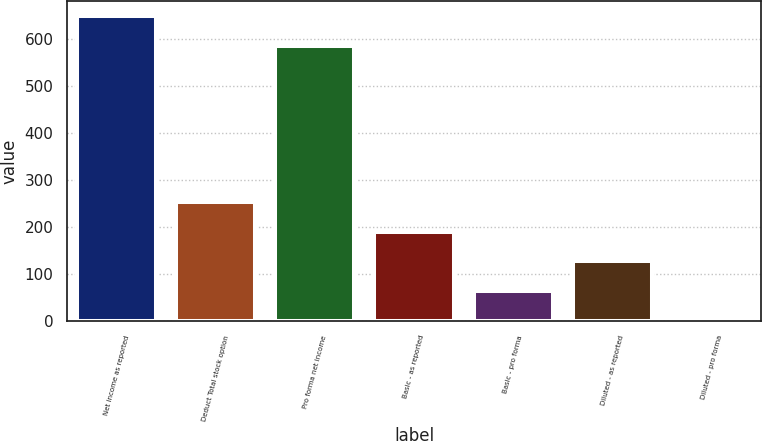Convert chart to OTSL. <chart><loc_0><loc_0><loc_500><loc_500><bar_chart><fcel>Net income as reported<fcel>Deduct Total stock option<fcel>Pro forma net income<fcel>Basic - as reported<fcel>Basic - pro forma<fcel>Diluted - as reported<fcel>Diluted - pro forma<nl><fcel>647.62<fcel>252.25<fcel>585<fcel>189.63<fcel>64.39<fcel>127.01<fcel>1.77<nl></chart> 